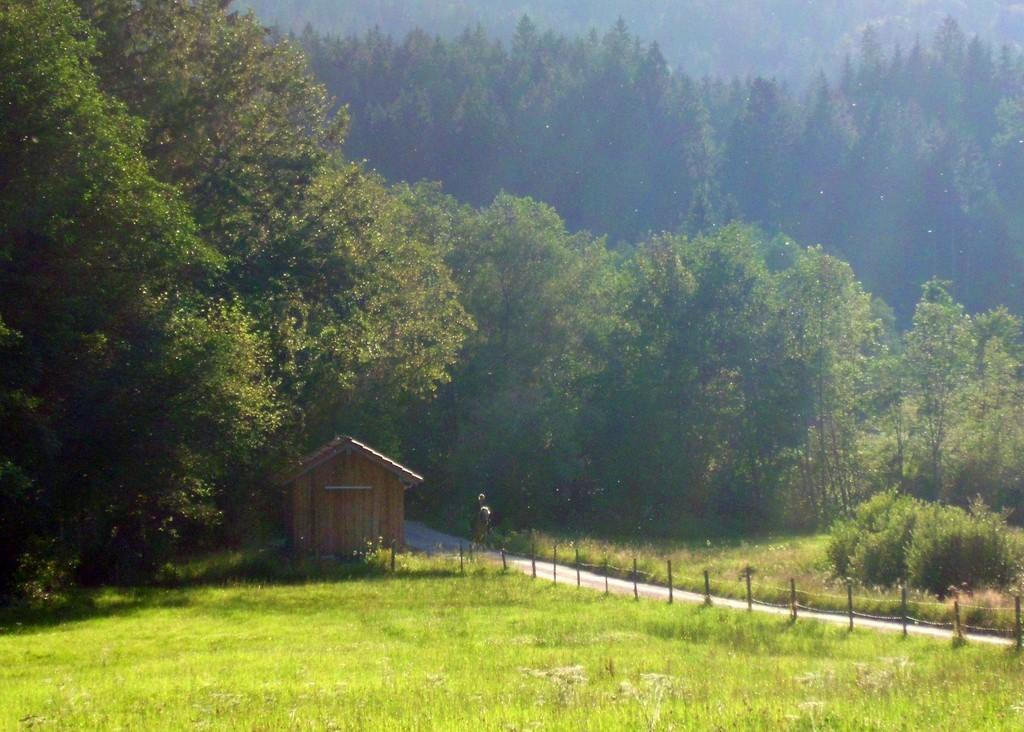What type of vegetation can be seen in the image? There is grass in the image. What type of pathway is visible in the image? There is a road in the image. What separates the grass from the road in the image? There is a fence in the image. What type of building is present in the image? There is a wooden house in the image. What can be seen in the distance in the image? Trees are present in the background of the image. Where is the cemetery located in the image? There is no cemetery present in the image. What type of truck is parked near the wooden house in the image? There is no truck present in the image. 